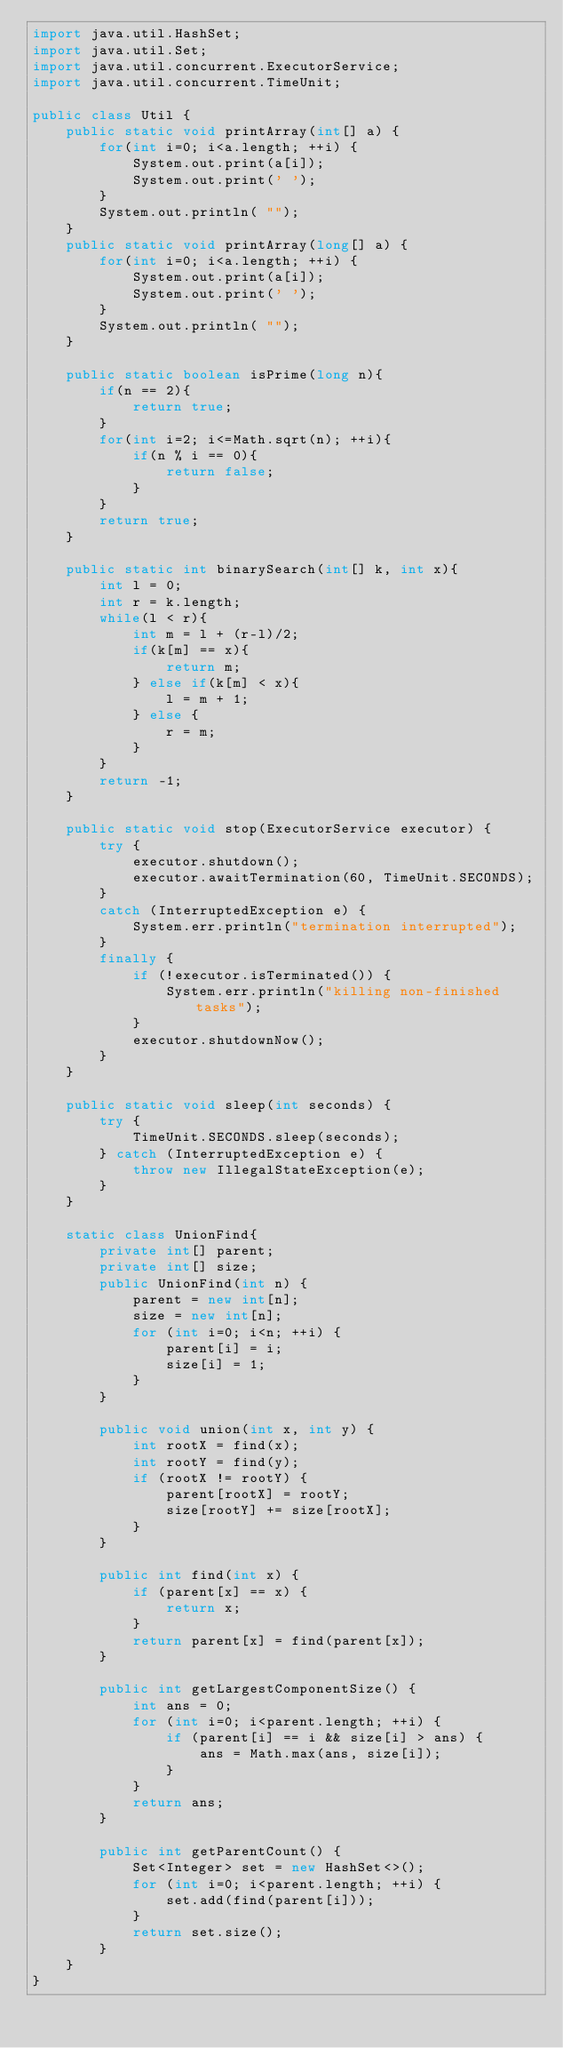<code> <loc_0><loc_0><loc_500><loc_500><_Java_>import java.util.HashSet;
import java.util.Set;
import java.util.concurrent.ExecutorService;
import java.util.concurrent.TimeUnit;

public class Util {
    public static void printArray(int[] a) {
        for(int i=0; i<a.length; ++i) {
            System.out.print(a[i]);
            System.out.print(' ');
        }
        System.out.println( "");
    }
    public static void printArray(long[] a) {
        for(int i=0; i<a.length; ++i) {
            System.out.print(a[i]);
            System.out.print(' ');
        }
        System.out.println( "");
    }

    public static boolean isPrime(long n){
        if(n == 2){
            return true;
        }
        for(int i=2; i<=Math.sqrt(n); ++i){
            if(n % i == 0){
                return false;
            }
        }
        return true;
    }

    public static int binarySearch(int[] k, int x){
        int l = 0;
        int r = k.length;
        while(l < r){
            int m = l + (r-l)/2;
            if(k[m] == x){
                return m;
            } else if(k[m] < x){
                l = m + 1;
            } else {
                r = m;
            }
        }
        return -1;
    }

    public static void stop(ExecutorService executor) {
        try {
            executor.shutdown();
            executor.awaitTermination(60, TimeUnit.SECONDS);
        }
        catch (InterruptedException e) {
            System.err.println("termination interrupted");
        }
        finally {
            if (!executor.isTerminated()) {
                System.err.println("killing non-finished tasks");
            }
            executor.shutdownNow();
        }
    }

    public static void sleep(int seconds) {
        try {
            TimeUnit.SECONDS.sleep(seconds);
        } catch (InterruptedException e) {
            throw new IllegalStateException(e);
        }
    }

    static class UnionFind{
        private int[] parent;
        private int[] size;
        public UnionFind(int n) {
            parent = new int[n];
            size = new int[n];
            for (int i=0; i<n; ++i) {
                parent[i] = i;
                size[i] = 1;
            }
        }

        public void union(int x, int y) {
            int rootX = find(x);
            int rootY = find(y);
            if (rootX != rootY) {
                parent[rootX] = rootY;
                size[rootY] += size[rootX];
            }
        }

        public int find(int x) {
            if (parent[x] == x) {
                return x;
            }
            return parent[x] = find(parent[x]);
        }

        public int getLargestComponentSize() {
            int ans = 0;
            for (int i=0; i<parent.length; ++i) {
                if (parent[i] == i && size[i] > ans) {
                    ans = Math.max(ans, size[i]);
                }
            }
            return ans;
        }

        public int getParentCount() {
            Set<Integer> set = new HashSet<>();
            for (int i=0; i<parent.length; ++i) {
                set.add(find(parent[i]));
            }
            return set.size();
        }
    }
}
</code> 